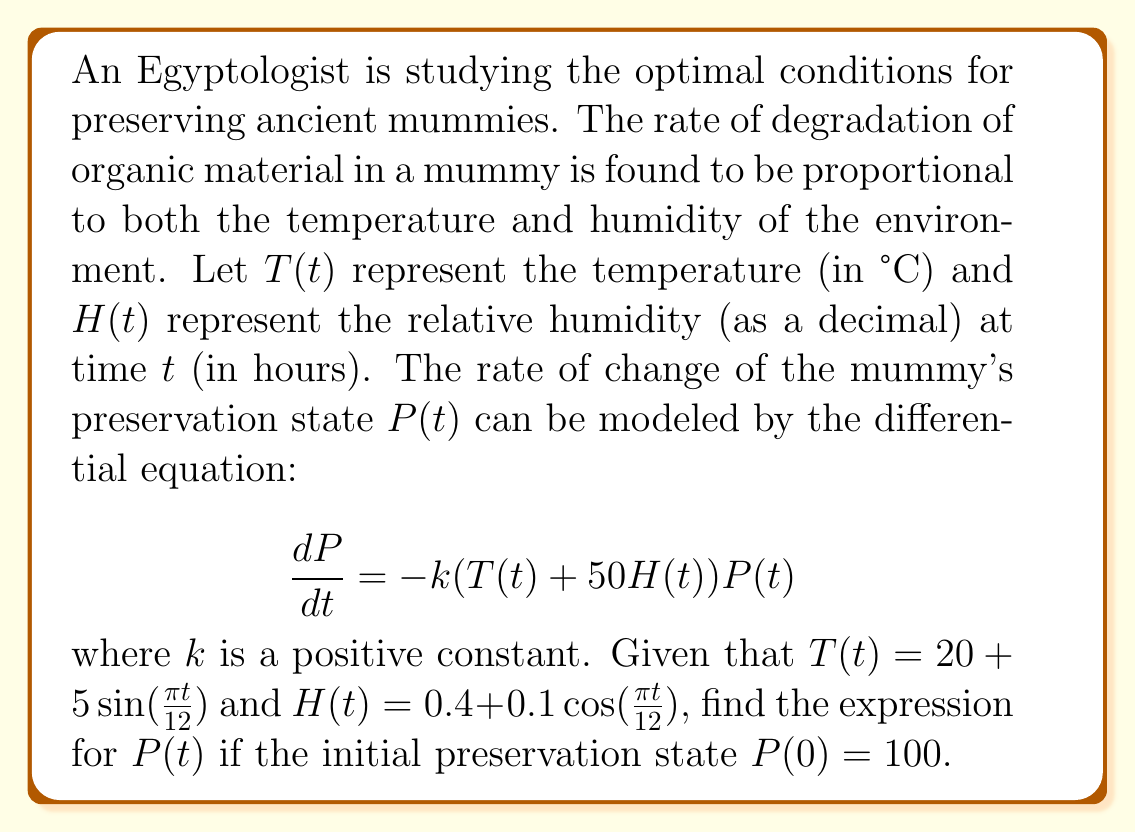What is the answer to this math problem? To solve this problem, we need to follow these steps:

1) First, we need to substitute the given expressions for $T(t)$ and $H(t)$ into the differential equation:

   $$\frac{dP}{dt} = -k(20 + 5\sin(\frac{\pi t}{12}) + 50(0.4 + 0.1\cos(\frac{\pi t}{12})))P(t)$$

2) Simplify the expression inside the parentheses:

   $$\frac{dP}{dt} = -k(20 + 5\sin(\frac{\pi t}{12}) + 20 + 5\cos(\frac{\pi t}{12}))P(t)$$
   $$\frac{dP}{dt} = -k(40 + 5\sin(\frac{\pi t}{12}) + 5\cos(\frac{\pi t}{12}))P(t)$$

3) This is a separable differential equation. We can rewrite it as:

   $$\frac{dP}{P} = -k(40 + 5\sin(\frac{\pi t}{12}) + 5\cos(\frac{\pi t}{12}))dt$$

4) Integrate both sides:

   $$\int \frac{dP}{P} = -k\int (40 + 5\sin(\frac{\pi t}{12}) + 5\cos(\frac{\pi t}{12}))dt$$

5) The left side integrates to $\ln|P|$. For the right side:

   $$\ln|P| = -k(40t - \frac{60}{\pi}\cos(\frac{\pi t}{12}) + \frac{60}{\pi}\sin(\frac{\pi t}{12})) + C$$

6) Apply the initial condition $P(0) = 100$:

   $$\ln(100) = C$$
   $$C = 4.6052$$

7) Therefore, the general solution is:

   $$\ln|P| = -k(40t - \frac{60}{\pi}\cos(\frac{\pi t}{12}) + \frac{60}{\pi}\sin(\frac{\pi t}{12})) + 4.6052$$

8) Solve for $P(t)$:

   $$P(t) = 100e^{-k(40t - \frac{60}{\pi}\cos(\frac{\pi t}{12}) + \frac{60}{\pi}\sin(\frac{\pi t}{12}))}$$

This is the expression for the preservation state $P(t)$ as a function of time $t$.
Answer: $P(t) = 100e^{-k(40t - \frac{60}{\pi}\cos(\frac{\pi t}{12}) + \frac{60}{\pi}\sin(\frac{\pi t}{12}))}$ 